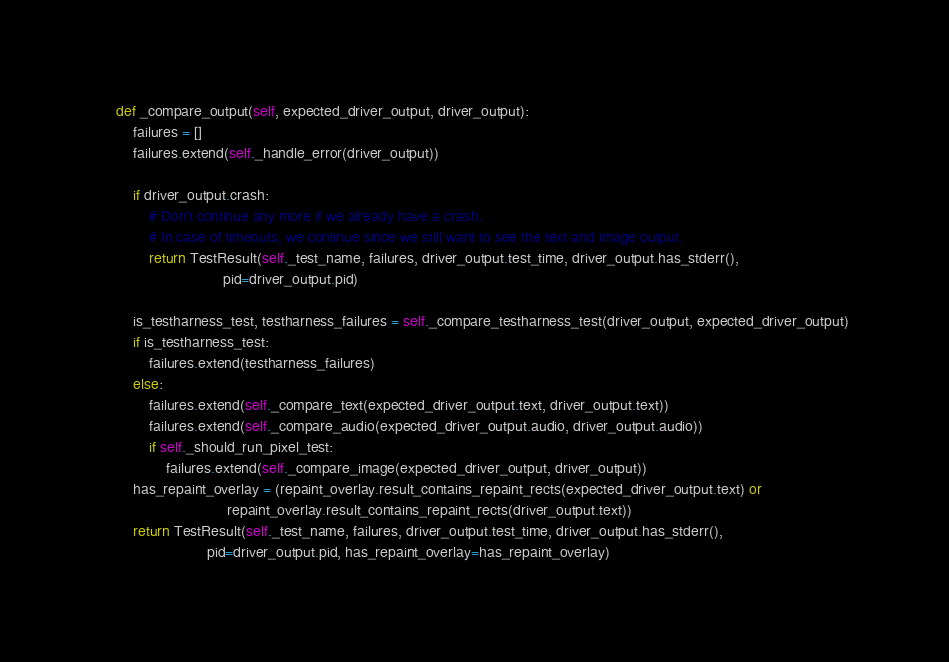Convert code to text. <code><loc_0><loc_0><loc_500><loc_500><_Python_>    def _compare_output(self, expected_driver_output, driver_output):
        failures = []
        failures.extend(self._handle_error(driver_output))

        if driver_output.crash:
            # Don't continue any more if we already have a crash.
            # In case of timeouts, we continue since we still want to see the text and image output.
            return TestResult(self._test_name, failures, driver_output.test_time, driver_output.has_stderr(),
                              pid=driver_output.pid)

        is_testharness_test, testharness_failures = self._compare_testharness_test(driver_output, expected_driver_output)
        if is_testharness_test:
            failures.extend(testharness_failures)
        else:
            failures.extend(self._compare_text(expected_driver_output.text, driver_output.text))
            failures.extend(self._compare_audio(expected_driver_output.audio, driver_output.audio))
            if self._should_run_pixel_test:
                failures.extend(self._compare_image(expected_driver_output, driver_output))
        has_repaint_overlay = (repaint_overlay.result_contains_repaint_rects(expected_driver_output.text) or
                               repaint_overlay.result_contains_repaint_rects(driver_output.text))
        return TestResult(self._test_name, failures, driver_output.test_time, driver_output.has_stderr(),
                          pid=driver_output.pid, has_repaint_overlay=has_repaint_overlay)
</code> 